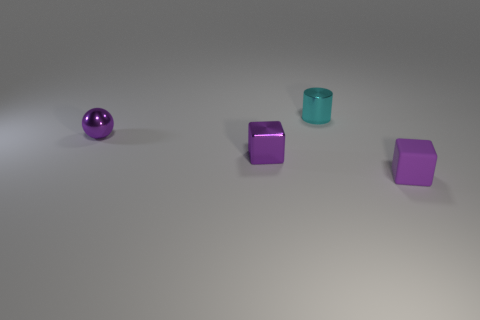What number of things are either purple metallic blocks or small green blocks?
Give a very brief answer. 1. What is the color of the thing that is both to the right of the purple metallic sphere and to the left of the small cyan cylinder?
Make the answer very short. Purple. Does the block right of the tiny cyan cylinder have the same material as the cylinder?
Provide a succinct answer. No. There is a rubber object; is its color the same as the cube that is behind the small purple rubber block?
Make the answer very short. Yes. There is a tiny ball; are there any purple objects in front of it?
Offer a terse response. Yes. Are there any brown rubber cylinders of the same size as the cyan cylinder?
Provide a succinct answer. No. There is a tiny metallic thing that is in front of the small purple ball; is its shape the same as the purple rubber object?
Make the answer very short. Yes. There is a purple thing right of the cylinder; what material is it?
Your response must be concise. Rubber. There is a metallic thing on the right side of the purple block on the left side of the cylinder; what shape is it?
Your answer should be compact. Cylinder. Do the cyan thing and the small purple object that is right of the small cyan metallic thing have the same shape?
Your response must be concise. No. 